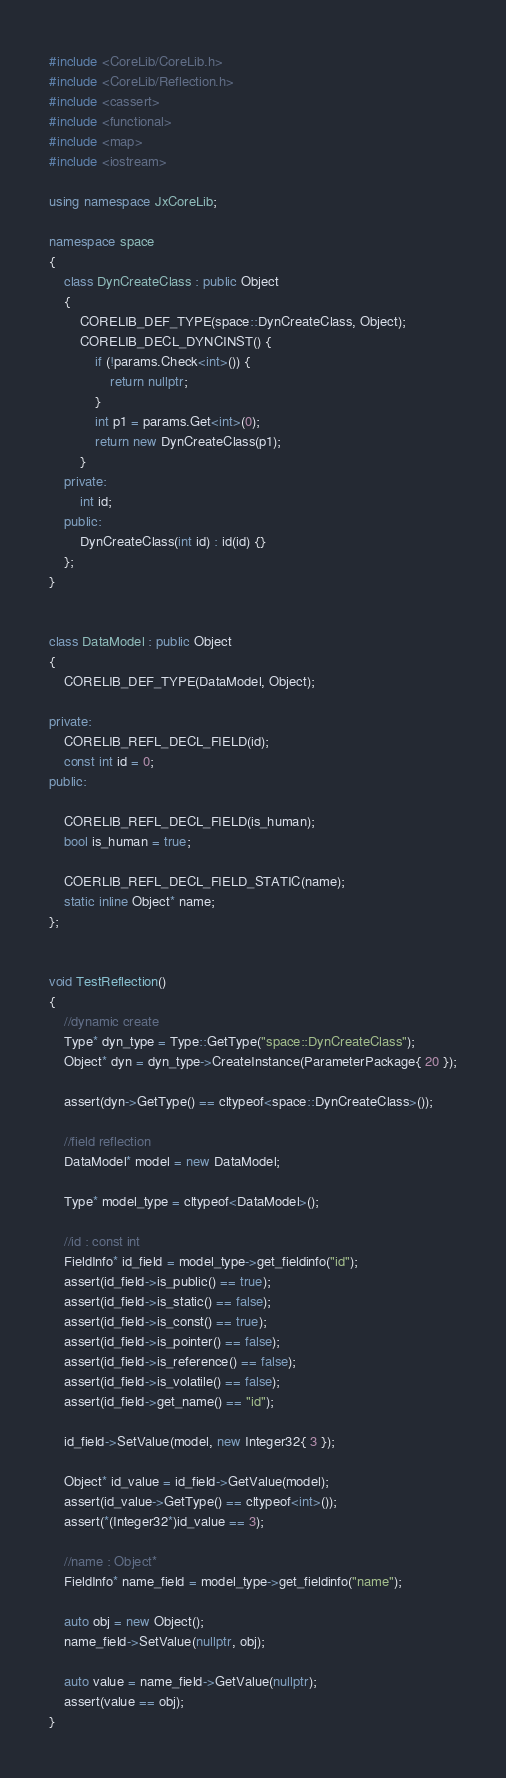<code> <loc_0><loc_0><loc_500><loc_500><_C++_>#include <CoreLib/CoreLib.h>
#include <CoreLib/Reflection.h>
#include <cassert>
#include <functional>
#include <map>
#include <iostream>

using namespace JxCoreLib;

namespace space
{
    class DynCreateClass : public Object
    {
        CORELIB_DEF_TYPE(space::DynCreateClass, Object);
        CORELIB_DECL_DYNCINST() {
            if (!params.Check<int>()) {
                return nullptr;
            }
            int p1 = params.Get<int>(0);
            return new DynCreateClass(p1);
        }
    private:
        int id;
    public:
        DynCreateClass(int id) : id(id) {}
    };
}


class DataModel : public Object
{
    CORELIB_DEF_TYPE(DataModel, Object);

private:
    CORELIB_REFL_DECL_FIELD(id);
    const int id = 0;
public:

    CORELIB_REFL_DECL_FIELD(is_human);
    bool is_human = true;

    COERLIB_REFL_DECL_FIELD_STATIC(name);
    static inline Object* name;
};


void TestReflection()
{
    //dynamic create
    Type* dyn_type = Type::GetType("space::DynCreateClass");
    Object* dyn = dyn_type->CreateInstance(ParameterPackage{ 20 });

    assert(dyn->GetType() == cltypeof<space::DynCreateClass>());

    //field reflection
    DataModel* model = new DataModel;

    Type* model_type = cltypeof<DataModel>();

    //id : const int
    FieldInfo* id_field = model_type->get_fieldinfo("id");
    assert(id_field->is_public() == true);
    assert(id_field->is_static() == false);
    assert(id_field->is_const() == true);
    assert(id_field->is_pointer() == false);
    assert(id_field->is_reference() == false);
    assert(id_field->is_volatile() == false);
    assert(id_field->get_name() == "id");

    id_field->SetValue(model, new Integer32{ 3 });

    Object* id_value = id_field->GetValue(model);
    assert(id_value->GetType() == cltypeof<int>());
    assert(*(Integer32*)id_value == 3);

    //name : Object*
    FieldInfo* name_field = model_type->get_fieldinfo("name");

    auto obj = new Object();
    name_field->SetValue(nullptr, obj);

    auto value = name_field->GetValue(nullptr);
    assert(value == obj);
}</code> 